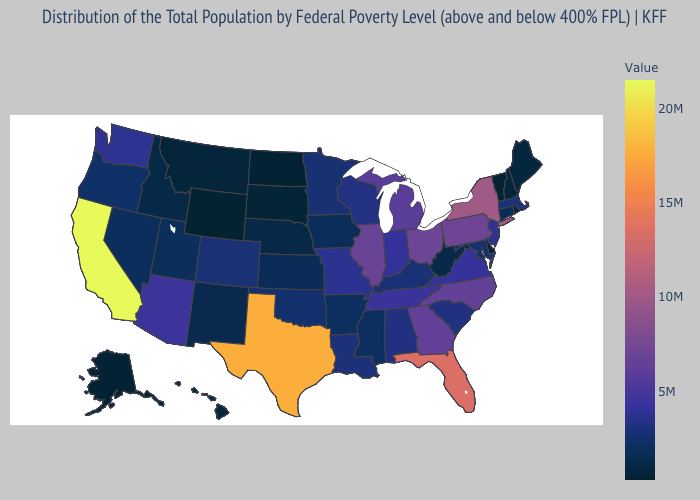Does Texas have a lower value than California?
Give a very brief answer. Yes. Does Illinois have a lower value than West Virginia?
Be succinct. No. Does New York have the highest value in the Northeast?
Keep it brief. Yes. Does Washington have a higher value than Texas?
Give a very brief answer. No. Among the states that border Alabama , which have the lowest value?
Answer briefly. Mississippi. Among the states that border Utah , does Wyoming have the lowest value?
Write a very short answer. Yes. Is the legend a continuous bar?
Short answer required. Yes. 